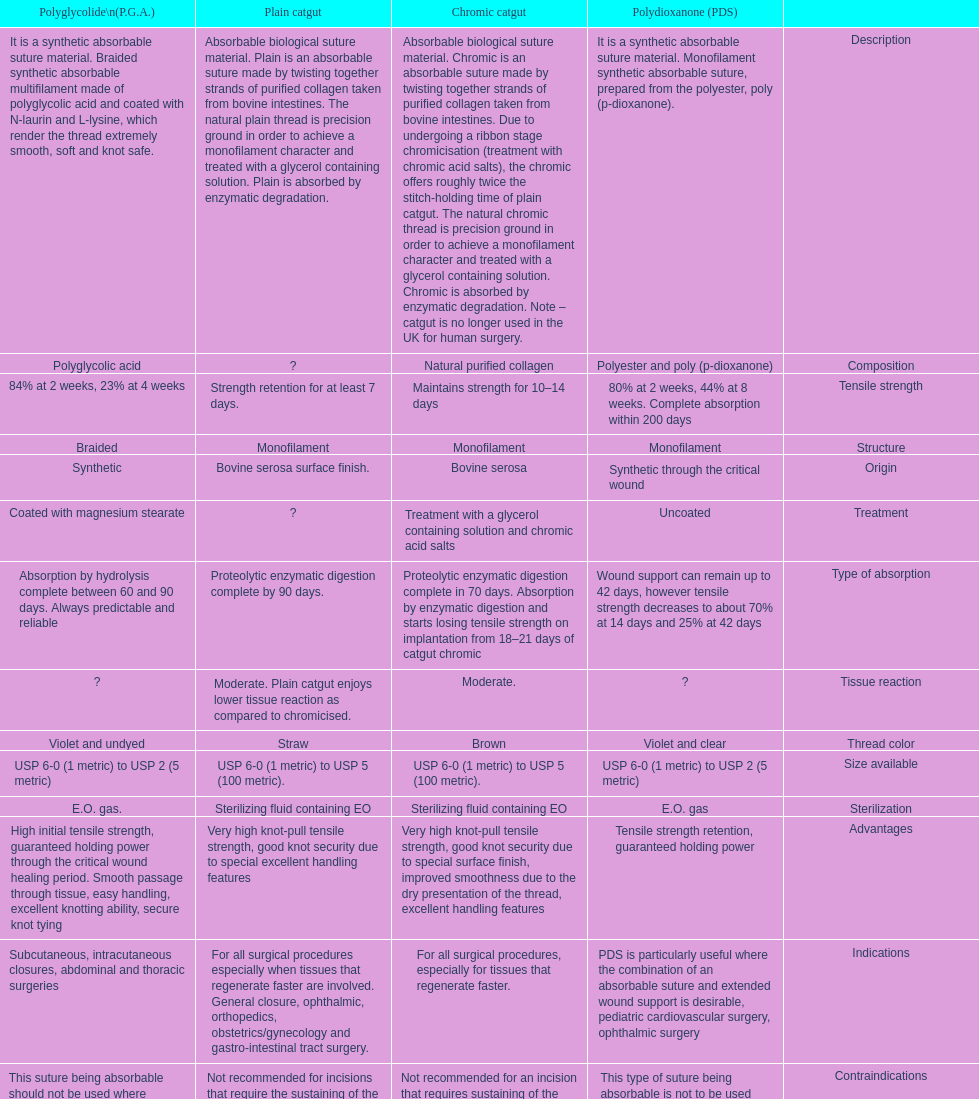The plain catgut maintains its strength for at least how many number of days? Strength retention for at least 7 days. 